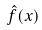Convert formula to latex. <formula><loc_0><loc_0><loc_500><loc_500>\hat { f } ( x )</formula> 